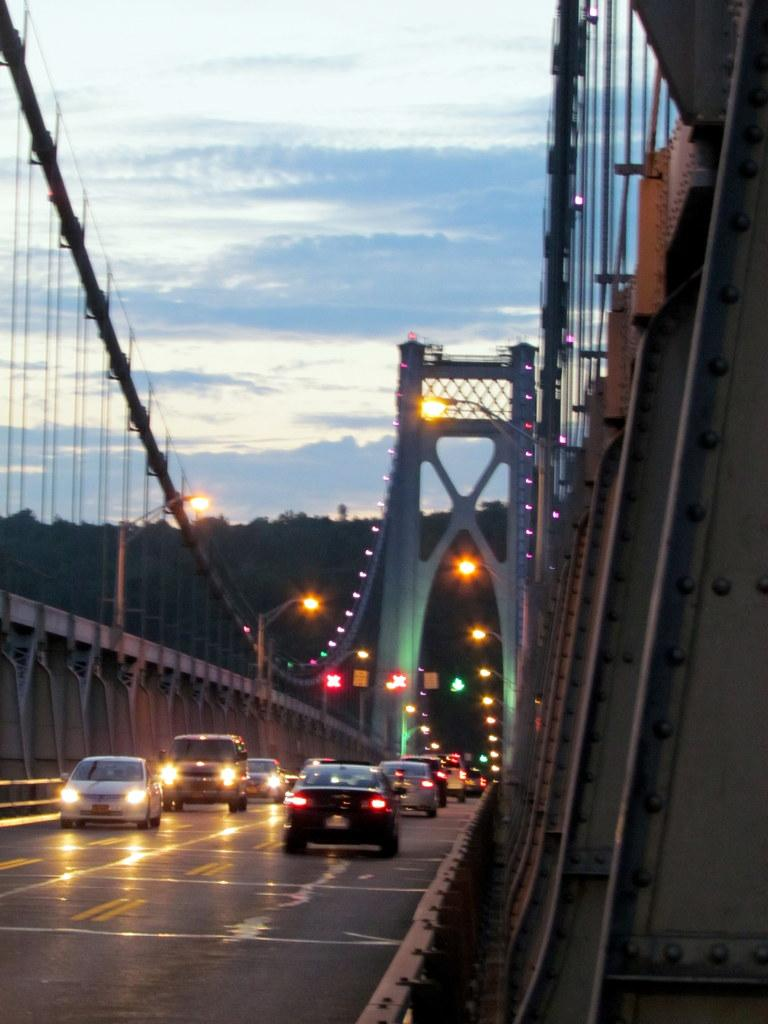What can be seen on the bridge in the image? There are vehicles on the bridge in the image. What is visible in the background of the image? In the background, there are lights, poles, hills, and the sky. Can you describe the poles in the background? The poles in the background are likely supporting the lights or other infrastructure. What type of terrain is visible in the background? The background features hills, suggesting a hilly or mountainous landscape. How many dimes can be seen on the bridge in the image? There are no dimes visible on the bridge or in the image. What type of test is being conducted on the vehicles in the image? There is no indication of a test being conducted on the vehicles in the image. 